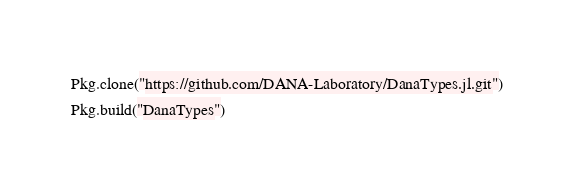<code> <loc_0><loc_0><loc_500><loc_500><_Julia_>Pkg.clone("https://github.com/DANA-Laboratory/DanaTypes.jl.git")
Pkg.build("DanaTypes")
</code> 